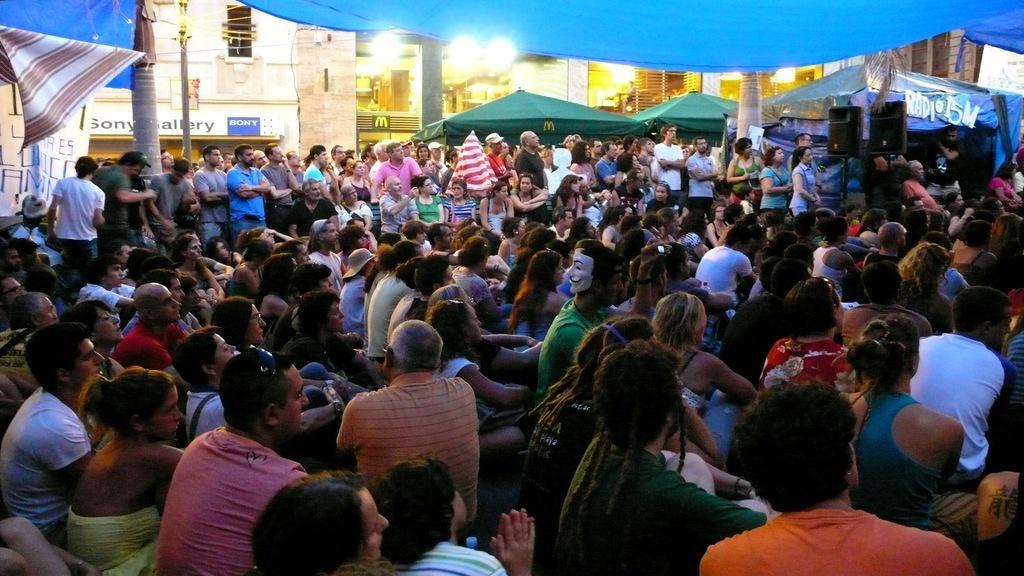In one or two sentences, can you explain what this image depicts? In this image I can see a group of people sitting and they are wearing different color dresses. Back I can see few tents,buildings,windows and boards. 